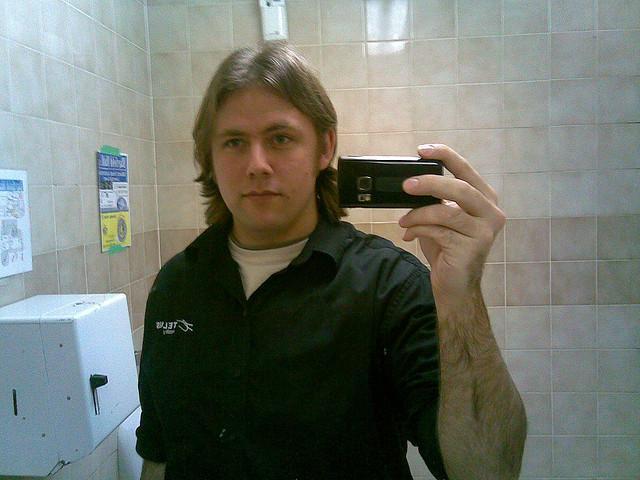How many cell phones are visible?
Give a very brief answer. 1. 